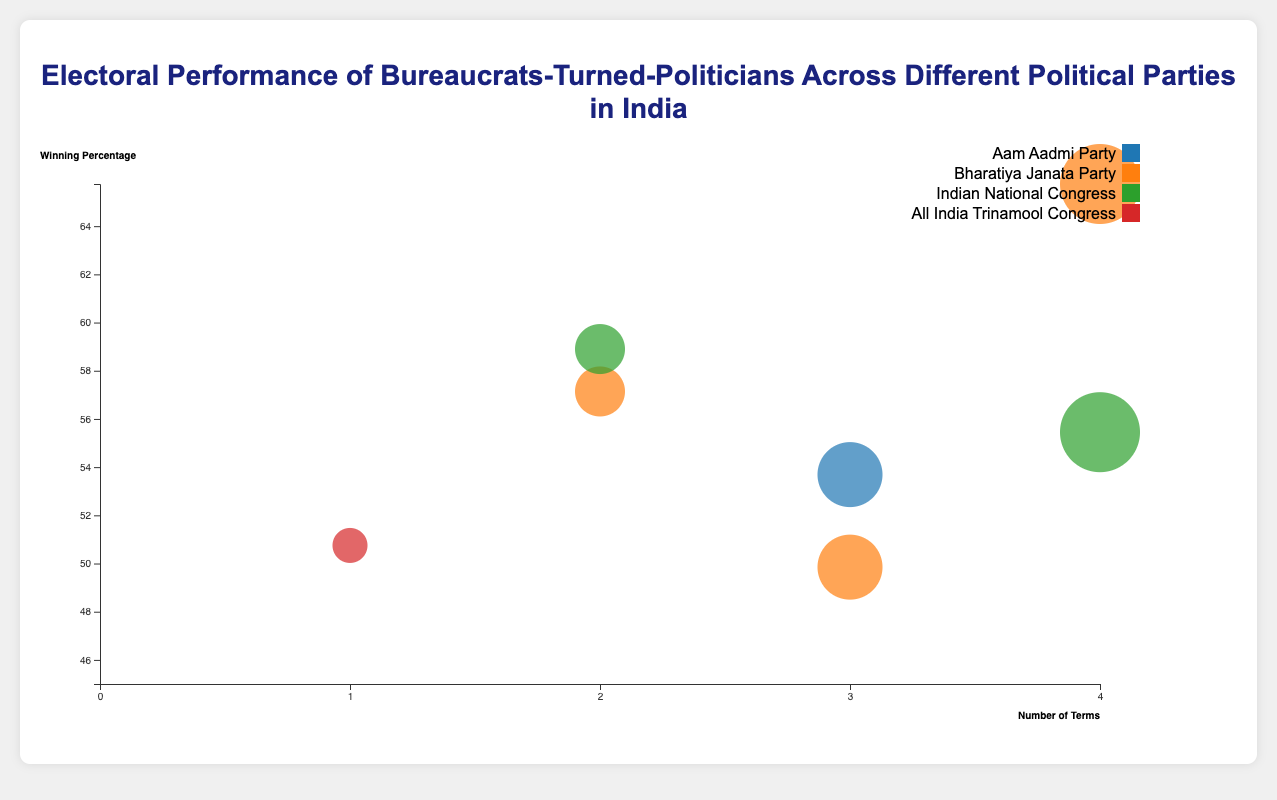What is the title of the chart? The title of the chart is written at the top section and clearly states the purpose of the visualization.
Answer: Electoral Performance of Bureaucrats-Turned-Politicians Across Different Political Parties in India How many terms has Manohar Parrikar served? Locate the bubble representing Manohar Parrikar on the chart. The number of terms served is indicated by the x-axis.
Answer: 4 Which political party color represents the most number of bureaucrats-turned-politicians? Look for the color having the most number of bubbles on the chart. Identify the political party associated with this color using the legend.
Answer: Bharatiya Janata Party What is the winning percentage of Arvind Kejriwal? Locate the bubble representing Arvind Kejriwal and refer to its vertical position along the y-axis.
Answer: 53.69 Who has the highest winning percentage among the politicians listed? Identify the bubble that is located highest on the y-axis. Read the tooltip or the position to find the corresponding name.
Answer: Manohar Parrikar How does the electoral performance of politicians from the Indian National Congress compare in terms of winning percentage? Locate the colors representing Indian National Congress and compare their vertical positions on the y-axis which indicates the winning percentage.
Answer: Ajit Jogi (58.90), Meira Kumar (55.45) Which politician has served the most number of terms and from which party? Identify the bubble on the furthest right side of the x-axis. This represents the politician with the maximum number of terms. Check the tooltip for additional information.
Answer: Manohar Parrikar, Bharatiya Janata Party What is the average number of terms served by bureaucrats-turned-politicians in this data? Sum the number of terms served by all politicians and divide by the total number of politicians. (3+4+2+3+2+1+4+1)/8 = 2.5.
Answer: 2.5 Which previous bureaucratic role has the most representation in the data? Identify the role mentioned most frequently in the tooltips upon hovering over different bubbles.
Answer: Indian Administrative Service Which politician representing an engineering background won a constituency in Goa? Locate the bubble for Goa constituency and check the tooltip for the bureaucratic background and name.
Answer: Manohar Parrikar 